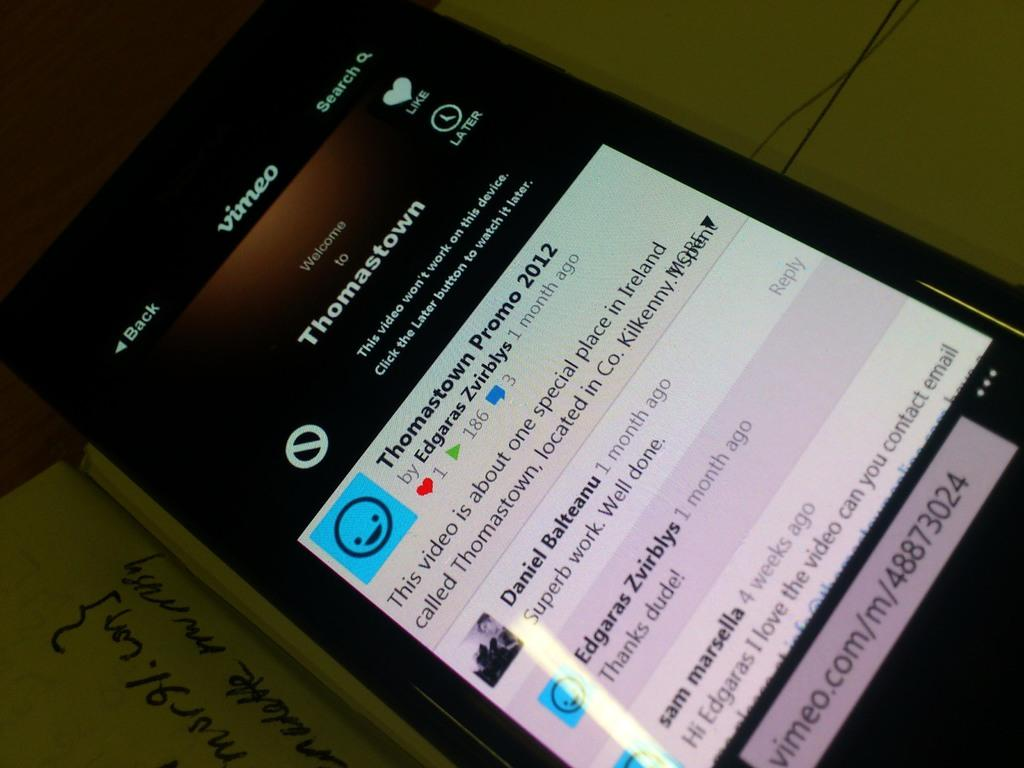<image>
Create a compact narrative representing the image presented. Black phone with a screen that says "thomastown" on top. 